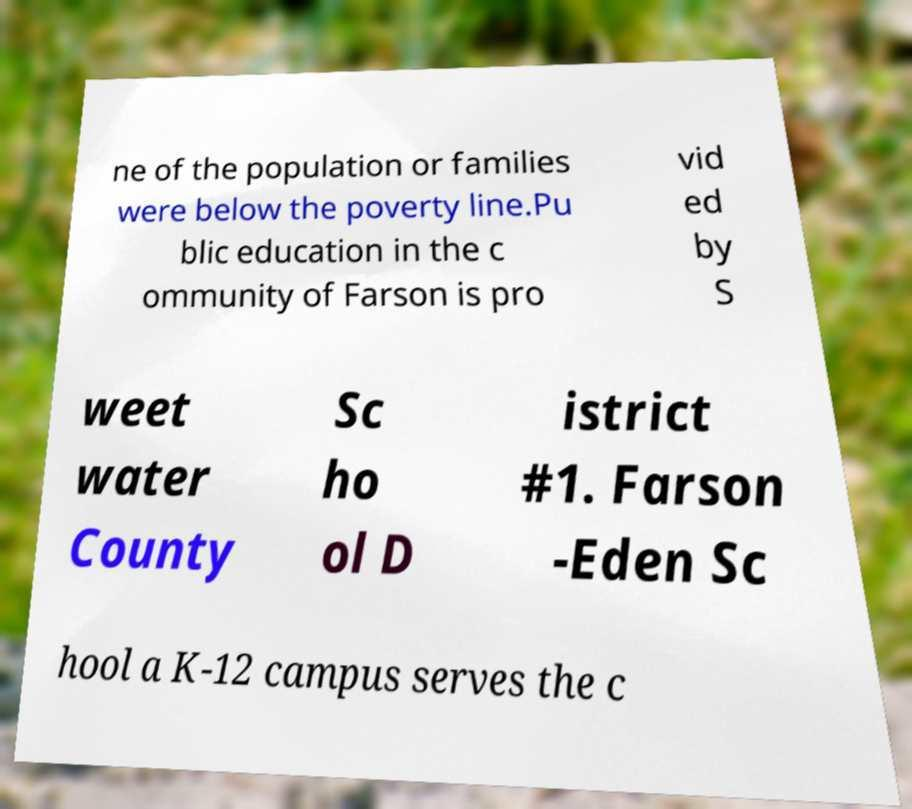I need the written content from this picture converted into text. Can you do that? ne of the population or families were below the poverty line.Pu blic education in the c ommunity of Farson is pro vid ed by S weet water County Sc ho ol D istrict #1. Farson -Eden Sc hool a K-12 campus serves the c 